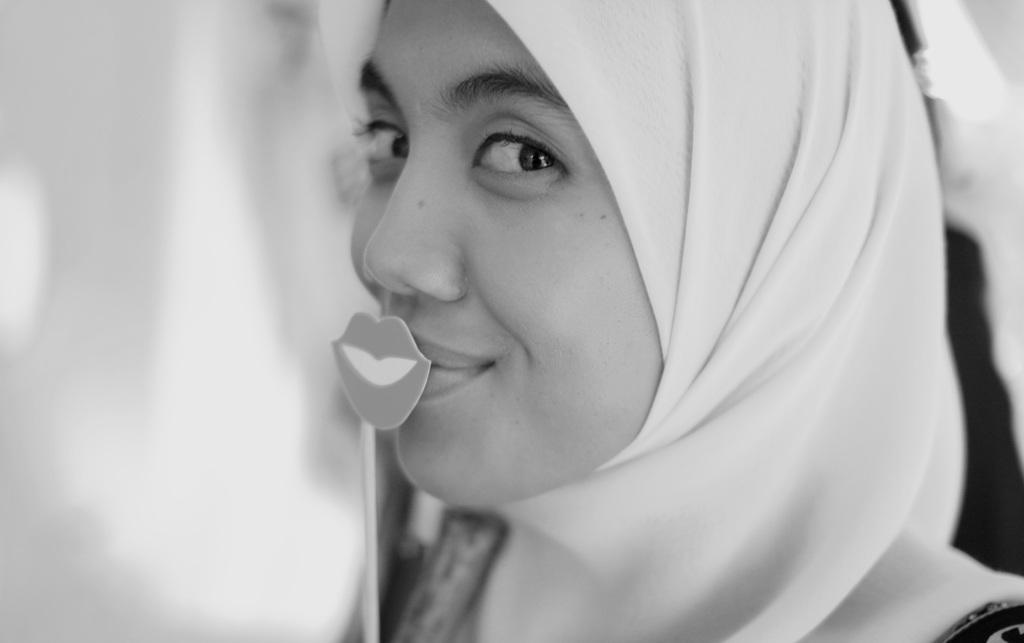What is the main subject of the image? There is a person in the image. What is the person holding in the image? The person is holding a booth prop stick. What is the person's facial expression in the image? The person is smiling. How would you describe the background of the image? The background of the image is blurry. How many pizzas are being served on the coach in the image? There are no pizzas or coaches present in the image. What type of sugar is being used to sweeten the person's drink in the image? There is no drink or sugar present in the image. 